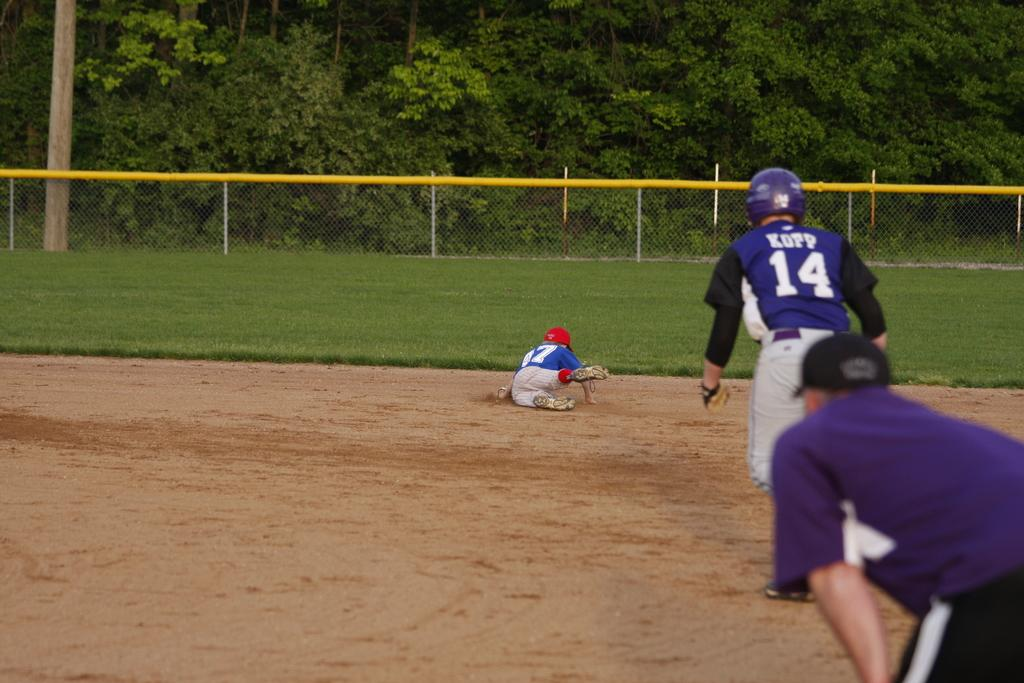<image>
Summarize the visual content of the image. Baseball player wearing number 14 going after another player. 